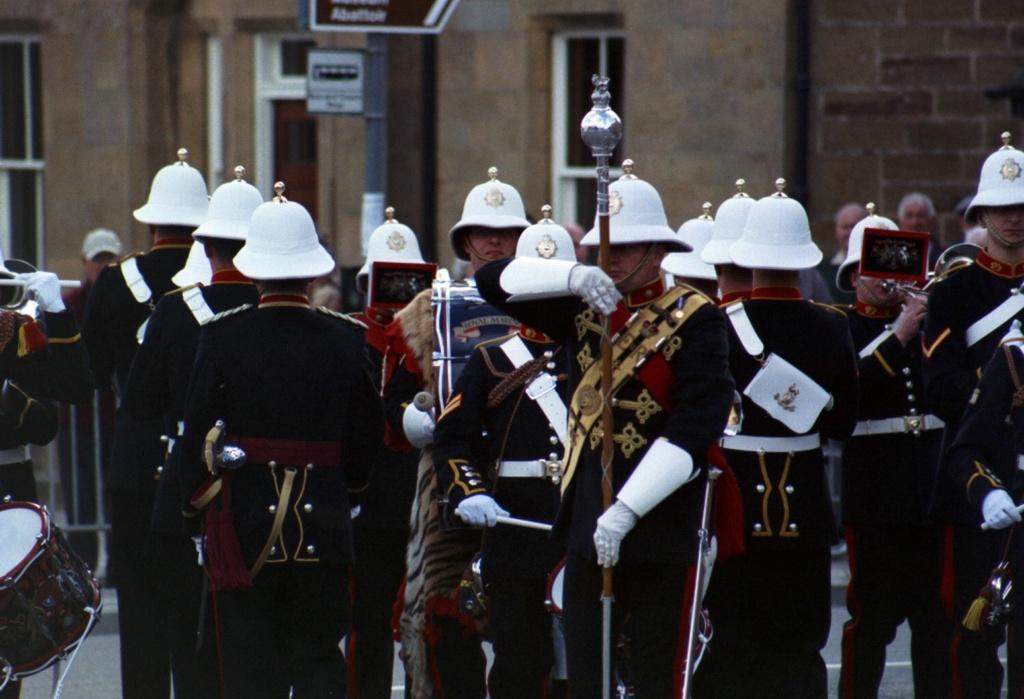Could you give a brief overview of what you see in this image? In the image there are many people standing with white caps on their heads. And also there are holding few objects in their hands and also there are playing musical instruments. There is a man holding a pole in the hand. Behind them there is a building with walls, windows and doors. 